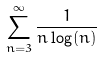<formula> <loc_0><loc_0><loc_500><loc_500>\sum _ { n = 3 } ^ { \infty } \frac { 1 } { n \log ( n ) }</formula> 